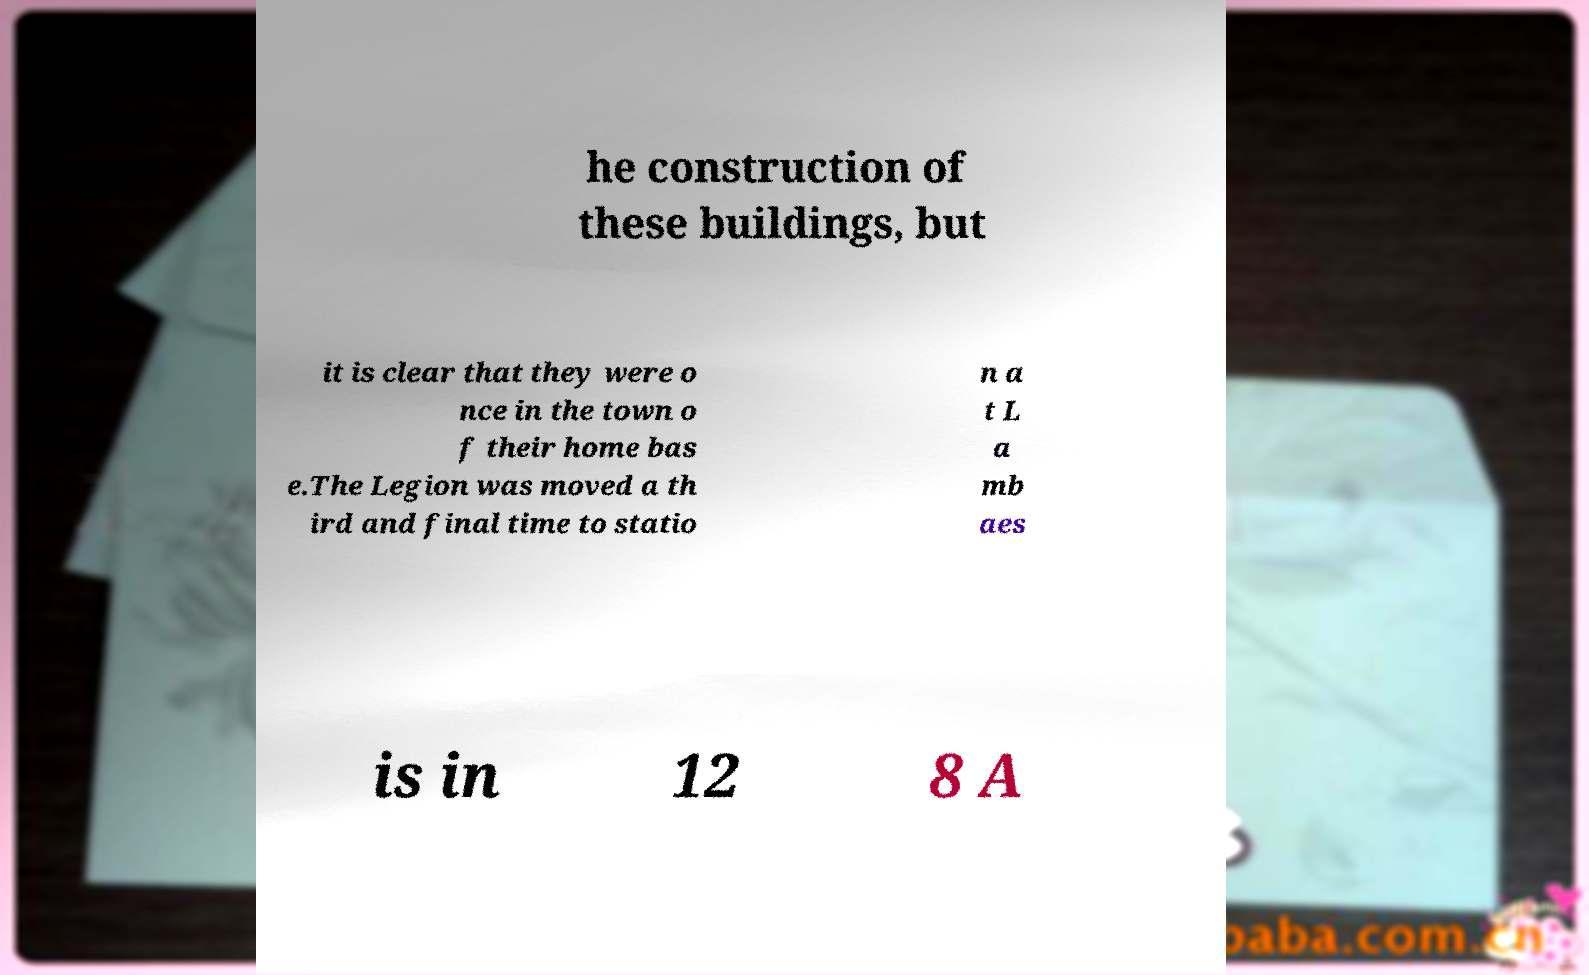I need the written content from this picture converted into text. Can you do that? he construction of these buildings, but it is clear that they were o nce in the town o f their home bas e.The Legion was moved a th ird and final time to statio n a t L a mb aes is in 12 8 A 